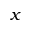Convert formula to latex. <formula><loc_0><loc_0><loc_500><loc_500>x</formula> 